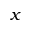Convert formula to latex. <formula><loc_0><loc_0><loc_500><loc_500>x</formula> 